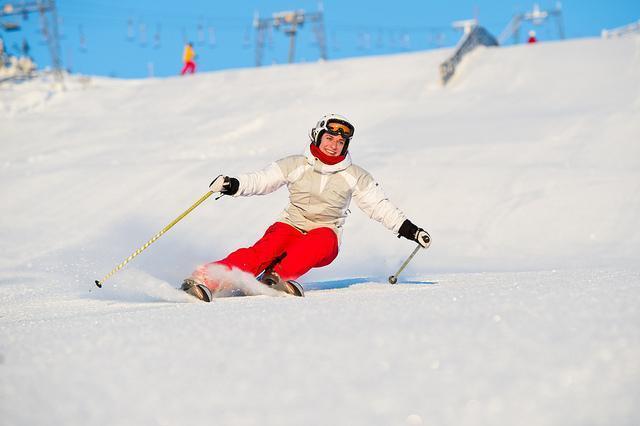How many flowers in the vase are yellow?
Give a very brief answer. 0. 